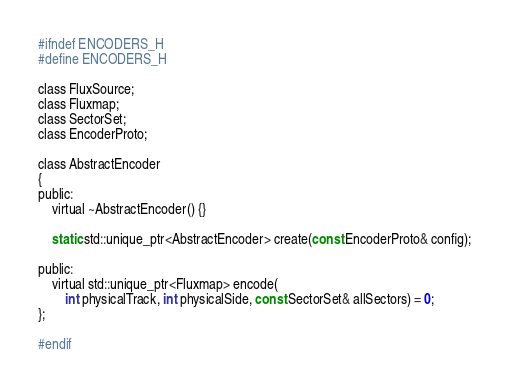<code> <loc_0><loc_0><loc_500><loc_500><_C_>#ifndef ENCODERS_H
#define ENCODERS_H

class FluxSource;
class Fluxmap;
class SectorSet;
class EncoderProto;

class AbstractEncoder
{
public:
    virtual ~AbstractEncoder() {}

	static std::unique_ptr<AbstractEncoder> create(const EncoderProto& config);

public:
    virtual std::unique_ptr<Fluxmap> encode(
        int physicalTrack, int physicalSide, const SectorSet& allSectors) = 0;
};

#endif

</code> 